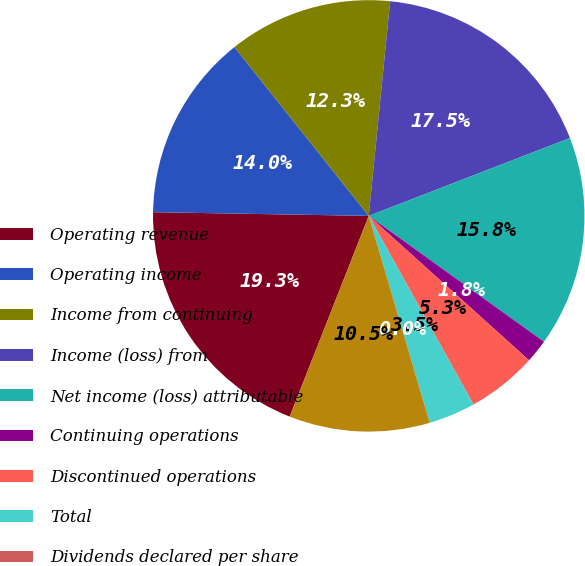Convert chart. <chart><loc_0><loc_0><loc_500><loc_500><pie_chart><fcel>Operating revenue<fcel>Operating income<fcel>Income from continuing<fcel>Income (loss) from<fcel>Net income (loss) attributable<fcel>Continuing operations<fcel>Discontinued operations<fcel>Total<fcel>Dividends declared per share<fcel>High<nl><fcel>19.3%<fcel>14.03%<fcel>12.28%<fcel>17.54%<fcel>15.79%<fcel>1.76%<fcel>5.26%<fcel>3.51%<fcel>0.0%<fcel>10.53%<nl></chart> 